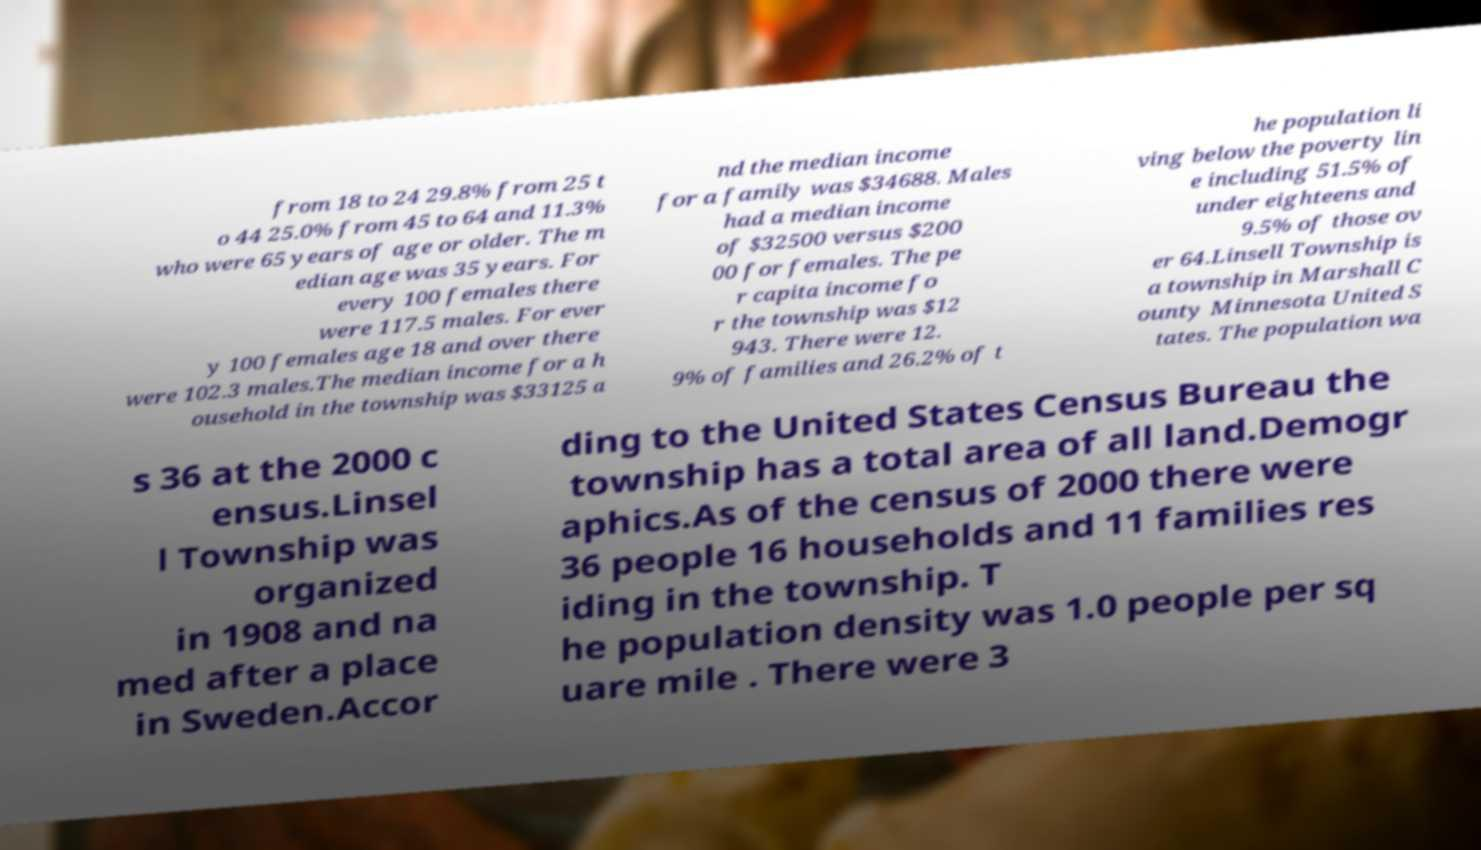Can you accurately transcribe the text from the provided image for me? from 18 to 24 29.8% from 25 t o 44 25.0% from 45 to 64 and 11.3% who were 65 years of age or older. The m edian age was 35 years. For every 100 females there were 117.5 males. For ever y 100 females age 18 and over there were 102.3 males.The median income for a h ousehold in the township was $33125 a nd the median income for a family was $34688. Males had a median income of $32500 versus $200 00 for females. The pe r capita income fo r the township was $12 943. There were 12. 9% of families and 26.2% of t he population li ving below the poverty lin e including 51.5% of under eighteens and 9.5% of those ov er 64.Linsell Township is a township in Marshall C ounty Minnesota United S tates. The population wa s 36 at the 2000 c ensus.Linsel l Township was organized in 1908 and na med after a place in Sweden.Accor ding to the United States Census Bureau the township has a total area of all land.Demogr aphics.As of the census of 2000 there were 36 people 16 households and 11 families res iding in the township. T he population density was 1.0 people per sq uare mile . There were 3 